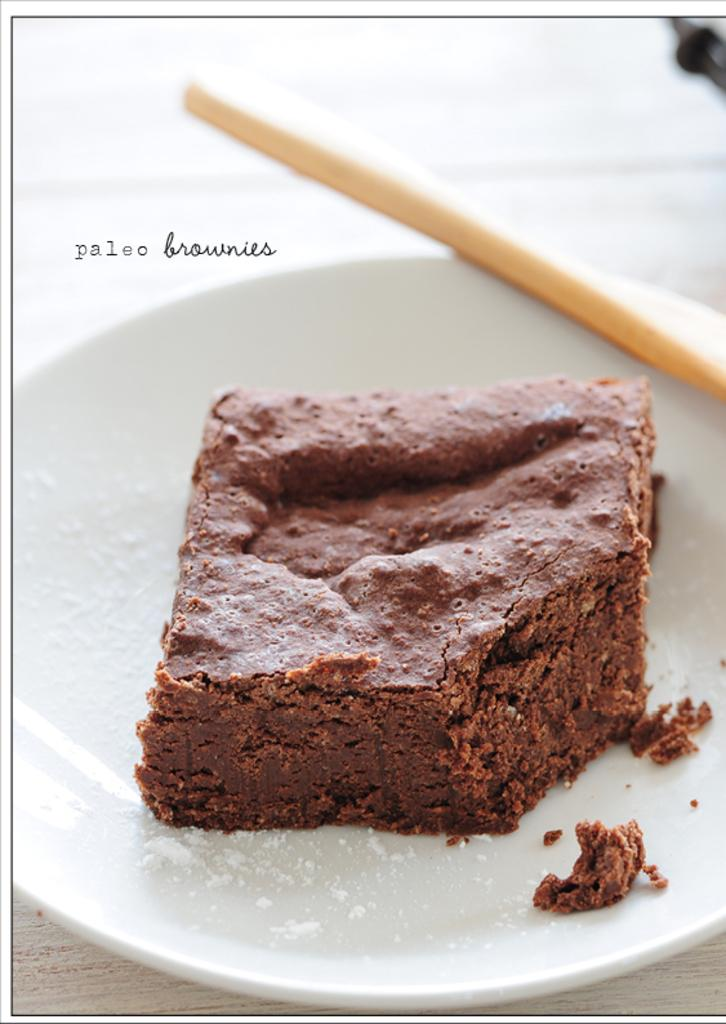What type of dessert is visible in the image? There is a brownie in the image. What is the brownie placed on? The brownie is on a white plate. What type of pancake can be seen in the image? There is no pancake present in the image; it features a brownie on a white plate. 